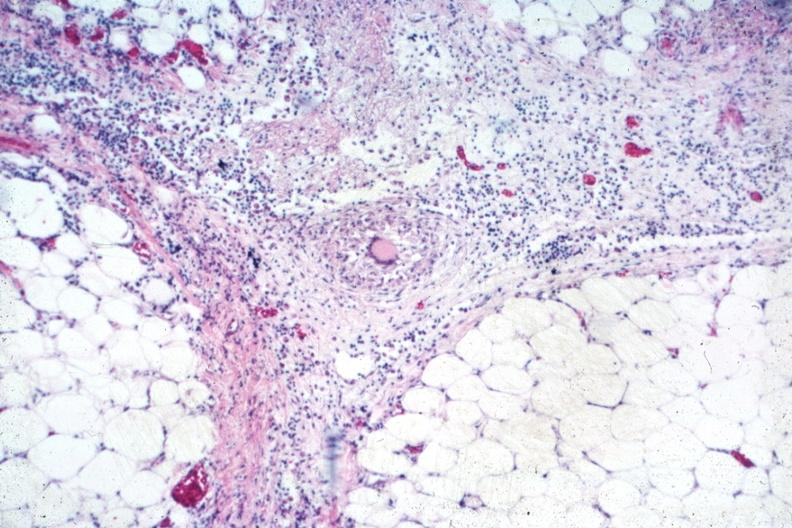how does this image show outstanding example of granuloma?
Answer the question using a single word or phrase. With langhans giant cell 